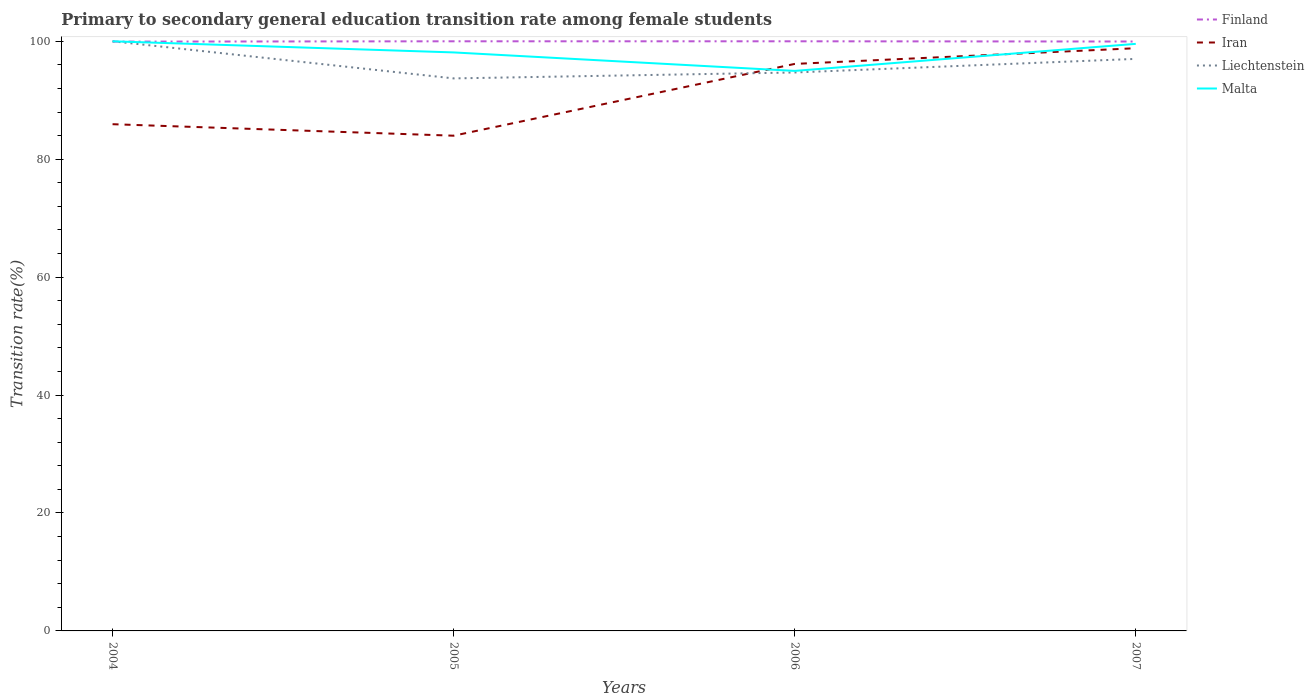How many different coloured lines are there?
Make the answer very short. 4. Does the line corresponding to Liechtenstein intersect with the line corresponding to Finland?
Your response must be concise. Yes. Is the number of lines equal to the number of legend labels?
Provide a succinct answer. Yes. Across all years, what is the maximum transition rate in Finland?
Offer a very short reply. 99.95. What is the total transition rate in Malta in the graph?
Your answer should be compact. 3.14. What is the difference between the highest and the second highest transition rate in Finland?
Provide a succinct answer. 0.05. How many lines are there?
Offer a terse response. 4. Are the values on the major ticks of Y-axis written in scientific E-notation?
Your response must be concise. No. Does the graph contain any zero values?
Your response must be concise. No. How many legend labels are there?
Make the answer very short. 4. How are the legend labels stacked?
Give a very brief answer. Vertical. What is the title of the graph?
Your answer should be very brief. Primary to secondary general education transition rate among female students. Does "Bermuda" appear as one of the legend labels in the graph?
Your response must be concise. No. What is the label or title of the Y-axis?
Your answer should be compact. Transition rate(%). What is the Transition rate(%) of Finland in 2004?
Offer a very short reply. 99.95. What is the Transition rate(%) in Iran in 2004?
Offer a terse response. 85.94. What is the Transition rate(%) in Liechtenstein in 2004?
Offer a terse response. 100. What is the Transition rate(%) of Malta in 2004?
Your answer should be compact. 100. What is the Transition rate(%) in Iran in 2005?
Keep it short and to the point. 83.99. What is the Transition rate(%) of Liechtenstein in 2005?
Your answer should be very brief. 93.71. What is the Transition rate(%) in Malta in 2005?
Keep it short and to the point. 98.11. What is the Transition rate(%) in Finland in 2006?
Keep it short and to the point. 100. What is the Transition rate(%) in Iran in 2006?
Offer a very short reply. 96.16. What is the Transition rate(%) of Liechtenstein in 2006?
Keep it short and to the point. 94.71. What is the Transition rate(%) in Malta in 2006?
Your response must be concise. 94.98. What is the Transition rate(%) in Finland in 2007?
Keep it short and to the point. 99.96. What is the Transition rate(%) in Iran in 2007?
Make the answer very short. 98.83. What is the Transition rate(%) in Liechtenstein in 2007?
Your answer should be compact. 97.02. What is the Transition rate(%) in Malta in 2007?
Provide a short and direct response. 99.57. Across all years, what is the maximum Transition rate(%) of Iran?
Give a very brief answer. 98.83. Across all years, what is the maximum Transition rate(%) of Liechtenstein?
Offer a very short reply. 100. Across all years, what is the minimum Transition rate(%) in Finland?
Provide a succinct answer. 99.95. Across all years, what is the minimum Transition rate(%) in Iran?
Offer a terse response. 83.99. Across all years, what is the minimum Transition rate(%) of Liechtenstein?
Offer a terse response. 93.71. Across all years, what is the minimum Transition rate(%) in Malta?
Give a very brief answer. 94.98. What is the total Transition rate(%) in Finland in the graph?
Your answer should be very brief. 399.91. What is the total Transition rate(%) in Iran in the graph?
Provide a short and direct response. 364.92. What is the total Transition rate(%) in Liechtenstein in the graph?
Your answer should be very brief. 385.44. What is the total Transition rate(%) of Malta in the graph?
Give a very brief answer. 392.66. What is the difference between the Transition rate(%) in Finland in 2004 and that in 2005?
Offer a very short reply. -0.05. What is the difference between the Transition rate(%) of Iran in 2004 and that in 2005?
Offer a very short reply. 1.95. What is the difference between the Transition rate(%) in Liechtenstein in 2004 and that in 2005?
Provide a succinct answer. 6.29. What is the difference between the Transition rate(%) in Malta in 2004 and that in 2005?
Keep it short and to the point. 1.89. What is the difference between the Transition rate(%) of Finland in 2004 and that in 2006?
Your answer should be compact. -0.05. What is the difference between the Transition rate(%) in Iran in 2004 and that in 2006?
Provide a succinct answer. -10.23. What is the difference between the Transition rate(%) of Liechtenstein in 2004 and that in 2006?
Your response must be concise. 5.29. What is the difference between the Transition rate(%) of Malta in 2004 and that in 2006?
Offer a very short reply. 5.02. What is the difference between the Transition rate(%) in Finland in 2004 and that in 2007?
Offer a terse response. -0.02. What is the difference between the Transition rate(%) of Iran in 2004 and that in 2007?
Your response must be concise. -12.89. What is the difference between the Transition rate(%) of Liechtenstein in 2004 and that in 2007?
Your answer should be compact. 2.98. What is the difference between the Transition rate(%) in Malta in 2004 and that in 2007?
Give a very brief answer. 0.43. What is the difference between the Transition rate(%) of Iran in 2005 and that in 2006?
Your response must be concise. -12.18. What is the difference between the Transition rate(%) of Liechtenstein in 2005 and that in 2006?
Make the answer very short. -1.01. What is the difference between the Transition rate(%) in Malta in 2005 and that in 2006?
Offer a very short reply. 3.13. What is the difference between the Transition rate(%) of Finland in 2005 and that in 2007?
Provide a succinct answer. 0.04. What is the difference between the Transition rate(%) of Iran in 2005 and that in 2007?
Provide a succinct answer. -14.84. What is the difference between the Transition rate(%) of Liechtenstein in 2005 and that in 2007?
Your answer should be very brief. -3.31. What is the difference between the Transition rate(%) in Malta in 2005 and that in 2007?
Offer a terse response. -1.45. What is the difference between the Transition rate(%) in Finland in 2006 and that in 2007?
Your answer should be very brief. 0.04. What is the difference between the Transition rate(%) in Iran in 2006 and that in 2007?
Make the answer very short. -2.66. What is the difference between the Transition rate(%) of Liechtenstein in 2006 and that in 2007?
Make the answer very short. -2.31. What is the difference between the Transition rate(%) of Malta in 2006 and that in 2007?
Offer a very short reply. -4.59. What is the difference between the Transition rate(%) in Finland in 2004 and the Transition rate(%) in Iran in 2005?
Make the answer very short. 15.96. What is the difference between the Transition rate(%) of Finland in 2004 and the Transition rate(%) of Liechtenstein in 2005?
Your response must be concise. 6.24. What is the difference between the Transition rate(%) in Finland in 2004 and the Transition rate(%) in Malta in 2005?
Provide a short and direct response. 1.83. What is the difference between the Transition rate(%) in Iran in 2004 and the Transition rate(%) in Liechtenstein in 2005?
Your answer should be very brief. -7.77. What is the difference between the Transition rate(%) in Iran in 2004 and the Transition rate(%) in Malta in 2005?
Make the answer very short. -12.17. What is the difference between the Transition rate(%) of Liechtenstein in 2004 and the Transition rate(%) of Malta in 2005?
Provide a short and direct response. 1.89. What is the difference between the Transition rate(%) in Finland in 2004 and the Transition rate(%) in Iran in 2006?
Make the answer very short. 3.78. What is the difference between the Transition rate(%) in Finland in 2004 and the Transition rate(%) in Liechtenstein in 2006?
Make the answer very short. 5.23. What is the difference between the Transition rate(%) of Finland in 2004 and the Transition rate(%) of Malta in 2006?
Provide a succinct answer. 4.97. What is the difference between the Transition rate(%) of Iran in 2004 and the Transition rate(%) of Liechtenstein in 2006?
Provide a succinct answer. -8.77. What is the difference between the Transition rate(%) in Iran in 2004 and the Transition rate(%) in Malta in 2006?
Keep it short and to the point. -9.04. What is the difference between the Transition rate(%) in Liechtenstein in 2004 and the Transition rate(%) in Malta in 2006?
Provide a short and direct response. 5.02. What is the difference between the Transition rate(%) of Finland in 2004 and the Transition rate(%) of Iran in 2007?
Your answer should be compact. 1.12. What is the difference between the Transition rate(%) in Finland in 2004 and the Transition rate(%) in Liechtenstein in 2007?
Offer a terse response. 2.93. What is the difference between the Transition rate(%) of Finland in 2004 and the Transition rate(%) of Malta in 2007?
Your answer should be very brief. 0.38. What is the difference between the Transition rate(%) of Iran in 2004 and the Transition rate(%) of Liechtenstein in 2007?
Your answer should be compact. -11.08. What is the difference between the Transition rate(%) in Iran in 2004 and the Transition rate(%) in Malta in 2007?
Your response must be concise. -13.63. What is the difference between the Transition rate(%) in Liechtenstein in 2004 and the Transition rate(%) in Malta in 2007?
Give a very brief answer. 0.43. What is the difference between the Transition rate(%) in Finland in 2005 and the Transition rate(%) in Iran in 2006?
Your answer should be very brief. 3.84. What is the difference between the Transition rate(%) of Finland in 2005 and the Transition rate(%) of Liechtenstein in 2006?
Offer a very short reply. 5.29. What is the difference between the Transition rate(%) in Finland in 2005 and the Transition rate(%) in Malta in 2006?
Offer a terse response. 5.02. What is the difference between the Transition rate(%) in Iran in 2005 and the Transition rate(%) in Liechtenstein in 2006?
Your response must be concise. -10.72. What is the difference between the Transition rate(%) of Iran in 2005 and the Transition rate(%) of Malta in 2006?
Your answer should be compact. -10.99. What is the difference between the Transition rate(%) of Liechtenstein in 2005 and the Transition rate(%) of Malta in 2006?
Ensure brevity in your answer.  -1.27. What is the difference between the Transition rate(%) in Finland in 2005 and the Transition rate(%) in Iran in 2007?
Your answer should be compact. 1.17. What is the difference between the Transition rate(%) in Finland in 2005 and the Transition rate(%) in Liechtenstein in 2007?
Keep it short and to the point. 2.98. What is the difference between the Transition rate(%) in Finland in 2005 and the Transition rate(%) in Malta in 2007?
Keep it short and to the point. 0.43. What is the difference between the Transition rate(%) of Iran in 2005 and the Transition rate(%) of Liechtenstein in 2007?
Offer a very short reply. -13.03. What is the difference between the Transition rate(%) in Iran in 2005 and the Transition rate(%) in Malta in 2007?
Provide a succinct answer. -15.58. What is the difference between the Transition rate(%) in Liechtenstein in 2005 and the Transition rate(%) in Malta in 2007?
Offer a very short reply. -5.86. What is the difference between the Transition rate(%) in Finland in 2006 and the Transition rate(%) in Iran in 2007?
Ensure brevity in your answer.  1.17. What is the difference between the Transition rate(%) in Finland in 2006 and the Transition rate(%) in Liechtenstein in 2007?
Give a very brief answer. 2.98. What is the difference between the Transition rate(%) in Finland in 2006 and the Transition rate(%) in Malta in 2007?
Your answer should be compact. 0.43. What is the difference between the Transition rate(%) in Iran in 2006 and the Transition rate(%) in Liechtenstein in 2007?
Make the answer very short. -0.85. What is the difference between the Transition rate(%) of Iran in 2006 and the Transition rate(%) of Malta in 2007?
Make the answer very short. -3.4. What is the difference between the Transition rate(%) in Liechtenstein in 2006 and the Transition rate(%) in Malta in 2007?
Your answer should be very brief. -4.85. What is the average Transition rate(%) of Finland per year?
Make the answer very short. 99.98. What is the average Transition rate(%) of Iran per year?
Offer a very short reply. 91.23. What is the average Transition rate(%) of Liechtenstein per year?
Your response must be concise. 96.36. What is the average Transition rate(%) of Malta per year?
Your answer should be very brief. 98.16. In the year 2004, what is the difference between the Transition rate(%) of Finland and Transition rate(%) of Iran?
Ensure brevity in your answer.  14.01. In the year 2004, what is the difference between the Transition rate(%) in Finland and Transition rate(%) in Liechtenstein?
Provide a succinct answer. -0.05. In the year 2004, what is the difference between the Transition rate(%) in Finland and Transition rate(%) in Malta?
Ensure brevity in your answer.  -0.05. In the year 2004, what is the difference between the Transition rate(%) in Iran and Transition rate(%) in Liechtenstein?
Your answer should be compact. -14.06. In the year 2004, what is the difference between the Transition rate(%) in Iran and Transition rate(%) in Malta?
Ensure brevity in your answer.  -14.06. In the year 2005, what is the difference between the Transition rate(%) in Finland and Transition rate(%) in Iran?
Give a very brief answer. 16.01. In the year 2005, what is the difference between the Transition rate(%) in Finland and Transition rate(%) in Liechtenstein?
Make the answer very short. 6.29. In the year 2005, what is the difference between the Transition rate(%) in Finland and Transition rate(%) in Malta?
Offer a terse response. 1.89. In the year 2005, what is the difference between the Transition rate(%) in Iran and Transition rate(%) in Liechtenstein?
Provide a succinct answer. -9.72. In the year 2005, what is the difference between the Transition rate(%) in Iran and Transition rate(%) in Malta?
Offer a very short reply. -14.12. In the year 2005, what is the difference between the Transition rate(%) of Liechtenstein and Transition rate(%) of Malta?
Provide a short and direct response. -4.41. In the year 2006, what is the difference between the Transition rate(%) in Finland and Transition rate(%) in Iran?
Your answer should be compact. 3.84. In the year 2006, what is the difference between the Transition rate(%) in Finland and Transition rate(%) in Liechtenstein?
Your answer should be compact. 5.29. In the year 2006, what is the difference between the Transition rate(%) in Finland and Transition rate(%) in Malta?
Keep it short and to the point. 5.02. In the year 2006, what is the difference between the Transition rate(%) in Iran and Transition rate(%) in Liechtenstein?
Ensure brevity in your answer.  1.45. In the year 2006, what is the difference between the Transition rate(%) in Iran and Transition rate(%) in Malta?
Offer a terse response. 1.19. In the year 2006, what is the difference between the Transition rate(%) in Liechtenstein and Transition rate(%) in Malta?
Offer a very short reply. -0.27. In the year 2007, what is the difference between the Transition rate(%) of Finland and Transition rate(%) of Iran?
Keep it short and to the point. 1.13. In the year 2007, what is the difference between the Transition rate(%) of Finland and Transition rate(%) of Liechtenstein?
Your answer should be compact. 2.94. In the year 2007, what is the difference between the Transition rate(%) of Finland and Transition rate(%) of Malta?
Provide a short and direct response. 0.4. In the year 2007, what is the difference between the Transition rate(%) of Iran and Transition rate(%) of Liechtenstein?
Your response must be concise. 1.81. In the year 2007, what is the difference between the Transition rate(%) in Iran and Transition rate(%) in Malta?
Offer a terse response. -0.74. In the year 2007, what is the difference between the Transition rate(%) in Liechtenstein and Transition rate(%) in Malta?
Your answer should be very brief. -2.55. What is the ratio of the Transition rate(%) in Iran in 2004 to that in 2005?
Give a very brief answer. 1.02. What is the ratio of the Transition rate(%) of Liechtenstein in 2004 to that in 2005?
Your response must be concise. 1.07. What is the ratio of the Transition rate(%) of Malta in 2004 to that in 2005?
Offer a terse response. 1.02. What is the ratio of the Transition rate(%) of Finland in 2004 to that in 2006?
Your answer should be compact. 1. What is the ratio of the Transition rate(%) in Iran in 2004 to that in 2006?
Your answer should be very brief. 0.89. What is the ratio of the Transition rate(%) of Liechtenstein in 2004 to that in 2006?
Keep it short and to the point. 1.06. What is the ratio of the Transition rate(%) in Malta in 2004 to that in 2006?
Make the answer very short. 1.05. What is the ratio of the Transition rate(%) in Finland in 2004 to that in 2007?
Provide a short and direct response. 1. What is the ratio of the Transition rate(%) of Iran in 2004 to that in 2007?
Keep it short and to the point. 0.87. What is the ratio of the Transition rate(%) of Liechtenstein in 2004 to that in 2007?
Your response must be concise. 1.03. What is the ratio of the Transition rate(%) in Finland in 2005 to that in 2006?
Provide a succinct answer. 1. What is the ratio of the Transition rate(%) of Iran in 2005 to that in 2006?
Ensure brevity in your answer.  0.87. What is the ratio of the Transition rate(%) of Liechtenstein in 2005 to that in 2006?
Ensure brevity in your answer.  0.99. What is the ratio of the Transition rate(%) of Malta in 2005 to that in 2006?
Give a very brief answer. 1.03. What is the ratio of the Transition rate(%) of Iran in 2005 to that in 2007?
Your answer should be very brief. 0.85. What is the ratio of the Transition rate(%) in Liechtenstein in 2005 to that in 2007?
Your response must be concise. 0.97. What is the ratio of the Transition rate(%) in Malta in 2005 to that in 2007?
Provide a short and direct response. 0.99. What is the ratio of the Transition rate(%) in Iran in 2006 to that in 2007?
Give a very brief answer. 0.97. What is the ratio of the Transition rate(%) of Liechtenstein in 2006 to that in 2007?
Make the answer very short. 0.98. What is the ratio of the Transition rate(%) of Malta in 2006 to that in 2007?
Offer a terse response. 0.95. What is the difference between the highest and the second highest Transition rate(%) of Finland?
Provide a short and direct response. 0. What is the difference between the highest and the second highest Transition rate(%) of Iran?
Ensure brevity in your answer.  2.66. What is the difference between the highest and the second highest Transition rate(%) of Liechtenstein?
Keep it short and to the point. 2.98. What is the difference between the highest and the second highest Transition rate(%) in Malta?
Provide a short and direct response. 0.43. What is the difference between the highest and the lowest Transition rate(%) of Finland?
Offer a very short reply. 0.05. What is the difference between the highest and the lowest Transition rate(%) of Iran?
Provide a short and direct response. 14.84. What is the difference between the highest and the lowest Transition rate(%) of Liechtenstein?
Keep it short and to the point. 6.29. What is the difference between the highest and the lowest Transition rate(%) of Malta?
Provide a succinct answer. 5.02. 